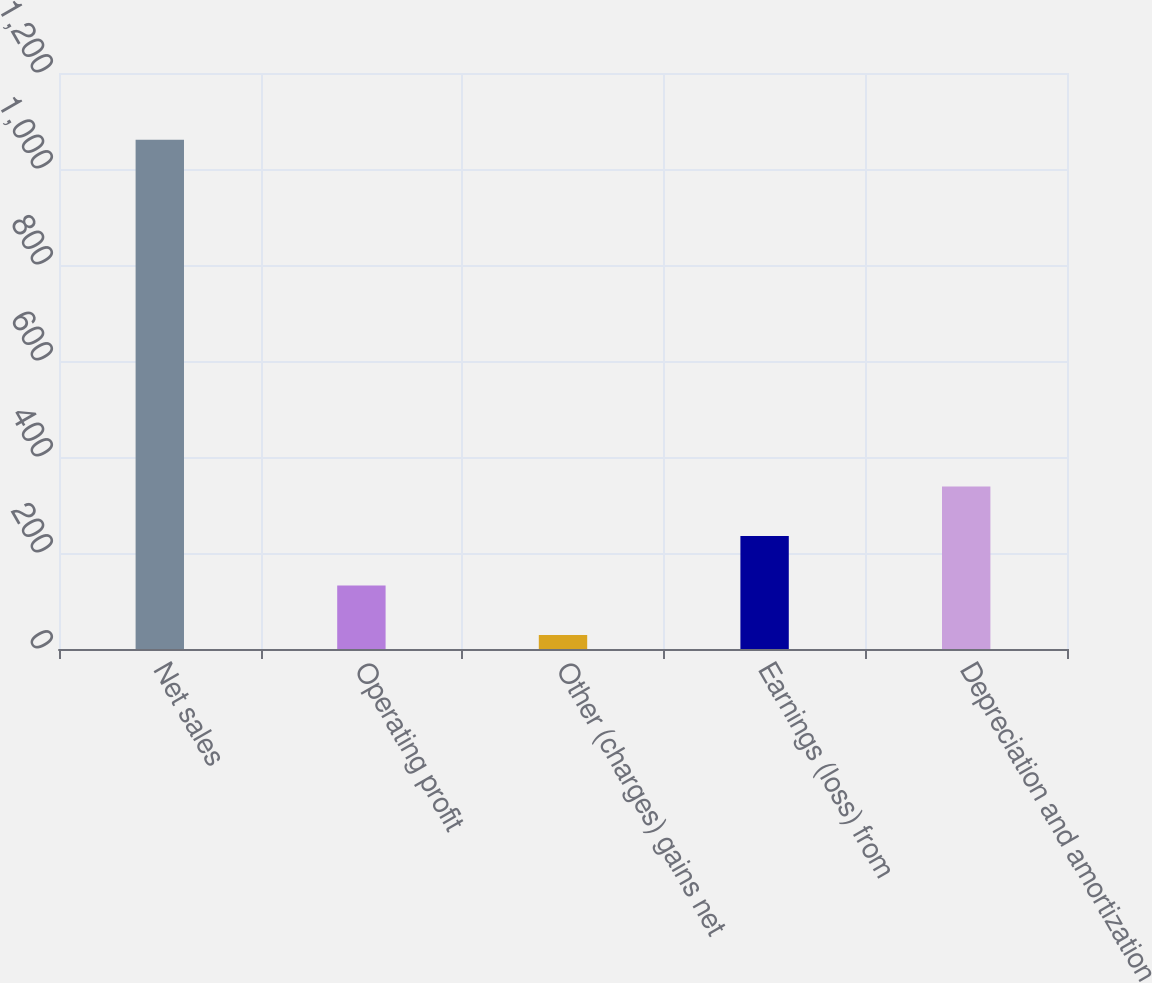<chart> <loc_0><loc_0><loc_500><loc_500><bar_chart><fcel>Net sales<fcel>Operating profit<fcel>Other (charges) gains net<fcel>Earnings (loss) from<fcel>Depreciation and amortization<nl><fcel>1061<fcel>132.2<fcel>29<fcel>235.4<fcel>338.6<nl></chart> 